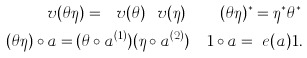<formula> <loc_0><loc_0><loc_500><loc_500>\ v ( \theta \eta ) = \ v ( \theta ) \ v ( \eta ) \quad ( \theta \eta ) ^ { * } = \eta ^ { * } \theta ^ { * } \\ ( \theta \eta ) \circ a = ( \theta \circ a ^ { ( 1 ) } ) ( \eta \circ a ^ { ( 2 ) } ) \quad 1 \circ a = \ e ( a ) 1 .</formula> 